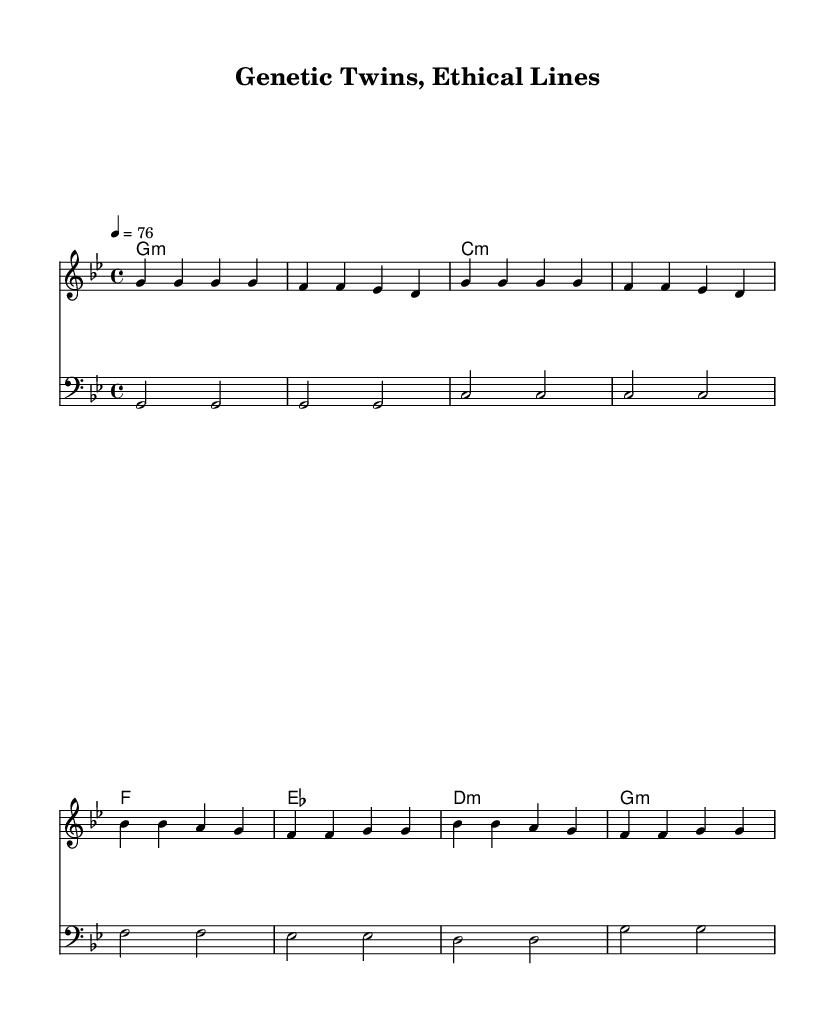What is the key signature of this music? The key signature is G minor, which has two flats (B flat and E flat).
Answer: G minor What is the time signature of the piece? The time signature is indicated as 4/4, meaning there are four beats in each measure.
Answer: 4/4 What is the tempo of the music? The tempo is marked as 76 beats per minute, indicating the speed at which the piece should be played.
Answer: 76 How many measures are in the verse? The verse consists of 8 measures, as indicated by the sequence of notes and bars shown in the melody line.
Answer: 8 What is the main theme addressed in the lyrics? The lyrics focus on the ethical implications of genetic manipulation and the nature of identical twins.
Answer: Ethical implications What is the harmonic structure used in the chorus? The chorus utilizes a repeating harmonic progression based on the chords listed, highlighting the emotional weight of the message.
Answer: Repeating harmonic progression What genre is this music classified as? The music is classified as reggae, characterized by its rhythmic style and thematic content.
Answer: Reggae 